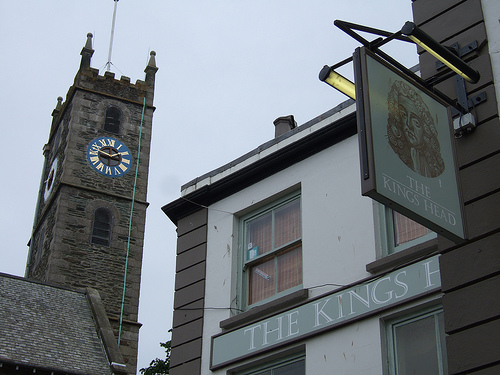Is the white clock on the right side of the photo?
Answer the question using a single word or phrase. No Does the window of the building look curved? Yes Which side is the man on? Right Which color is the large clock? Blue Does the blue clock look round and small? No Do you see any large buses or words? Yes What is on the sign on the front of the building? Words Do you see clocks or towers in this image? Yes Is the large clock on the right side of the picture? No 